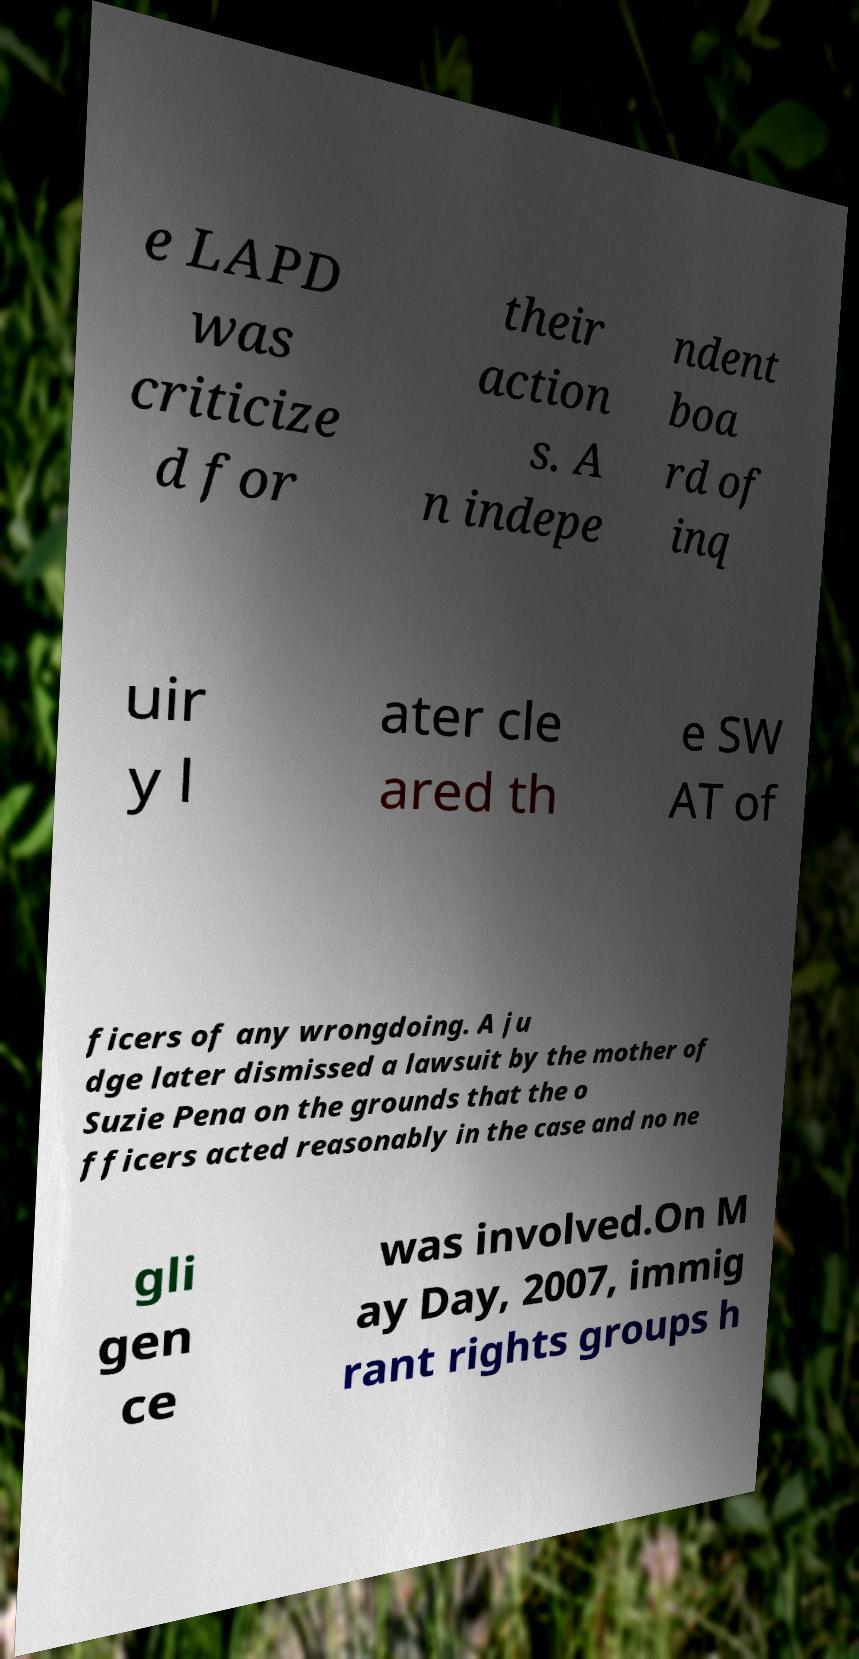Please read and relay the text visible in this image. What does it say? e LAPD was criticize d for their action s. A n indepe ndent boa rd of inq uir y l ater cle ared th e SW AT of ficers of any wrongdoing. A ju dge later dismissed a lawsuit by the mother of Suzie Pena on the grounds that the o fficers acted reasonably in the case and no ne gli gen ce was involved.On M ay Day, 2007, immig rant rights groups h 